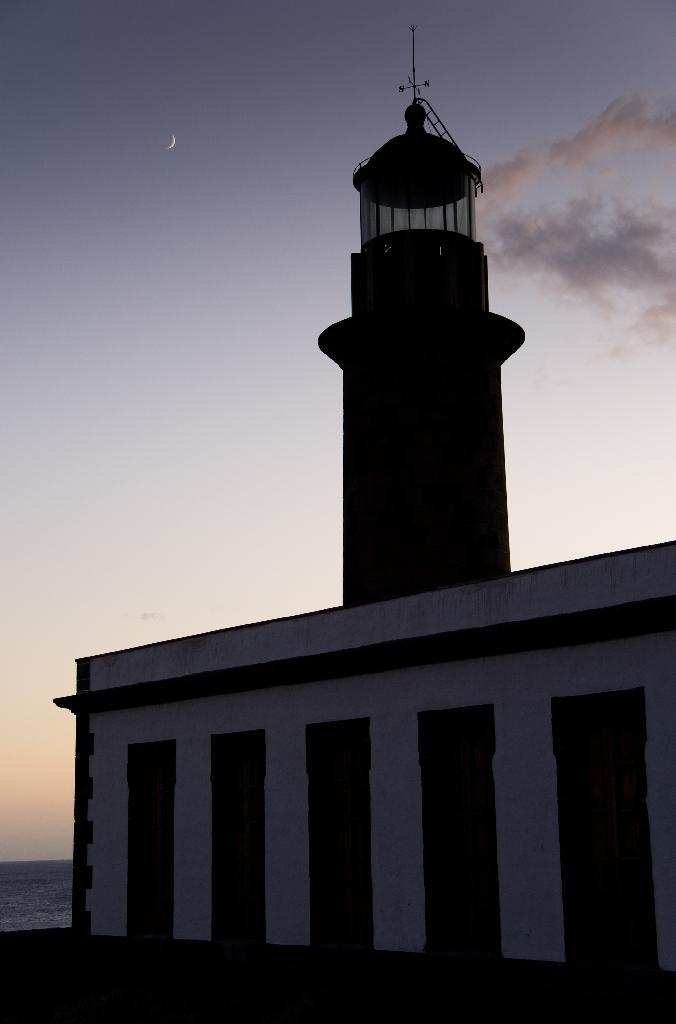What type of structure is present in the image? There is a building with a tower in the image. Where is the building located? The building is located near the sea. What is the color of the sky in the image? The sky is blue in color. Are there any weather conditions visible in the sky? Yes, there are clouds visible in the sky. What type of fuel is being used by the building in the image? There is no information about the building's fuel source in the image. 